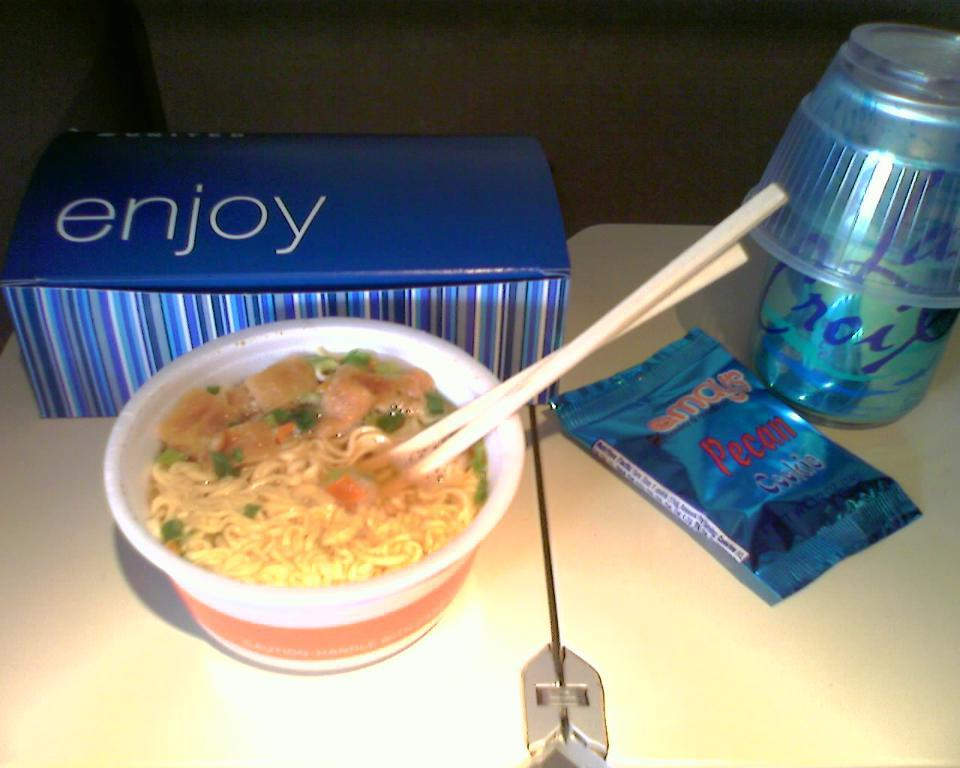Provide a one-sentence caption for the provided image. A blue striped box with the word "enjoy" on it with a bowl of ramen with chopsticks, a pecan cookie with a La Croix drink on the table. 